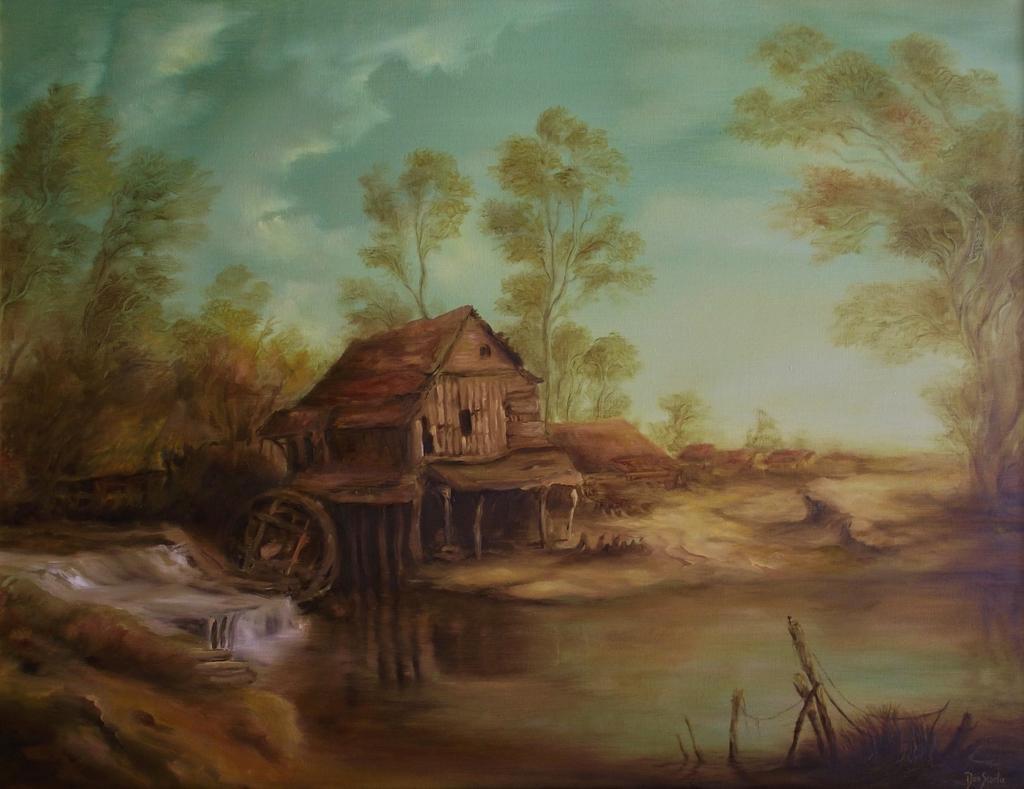Describe this image in one or two sentences. This image consists of a painting. At the bottom, I can see the water. In the middle of the image there is a wooden house. In the background there are some trees. At the top of the image I can see the sky. 